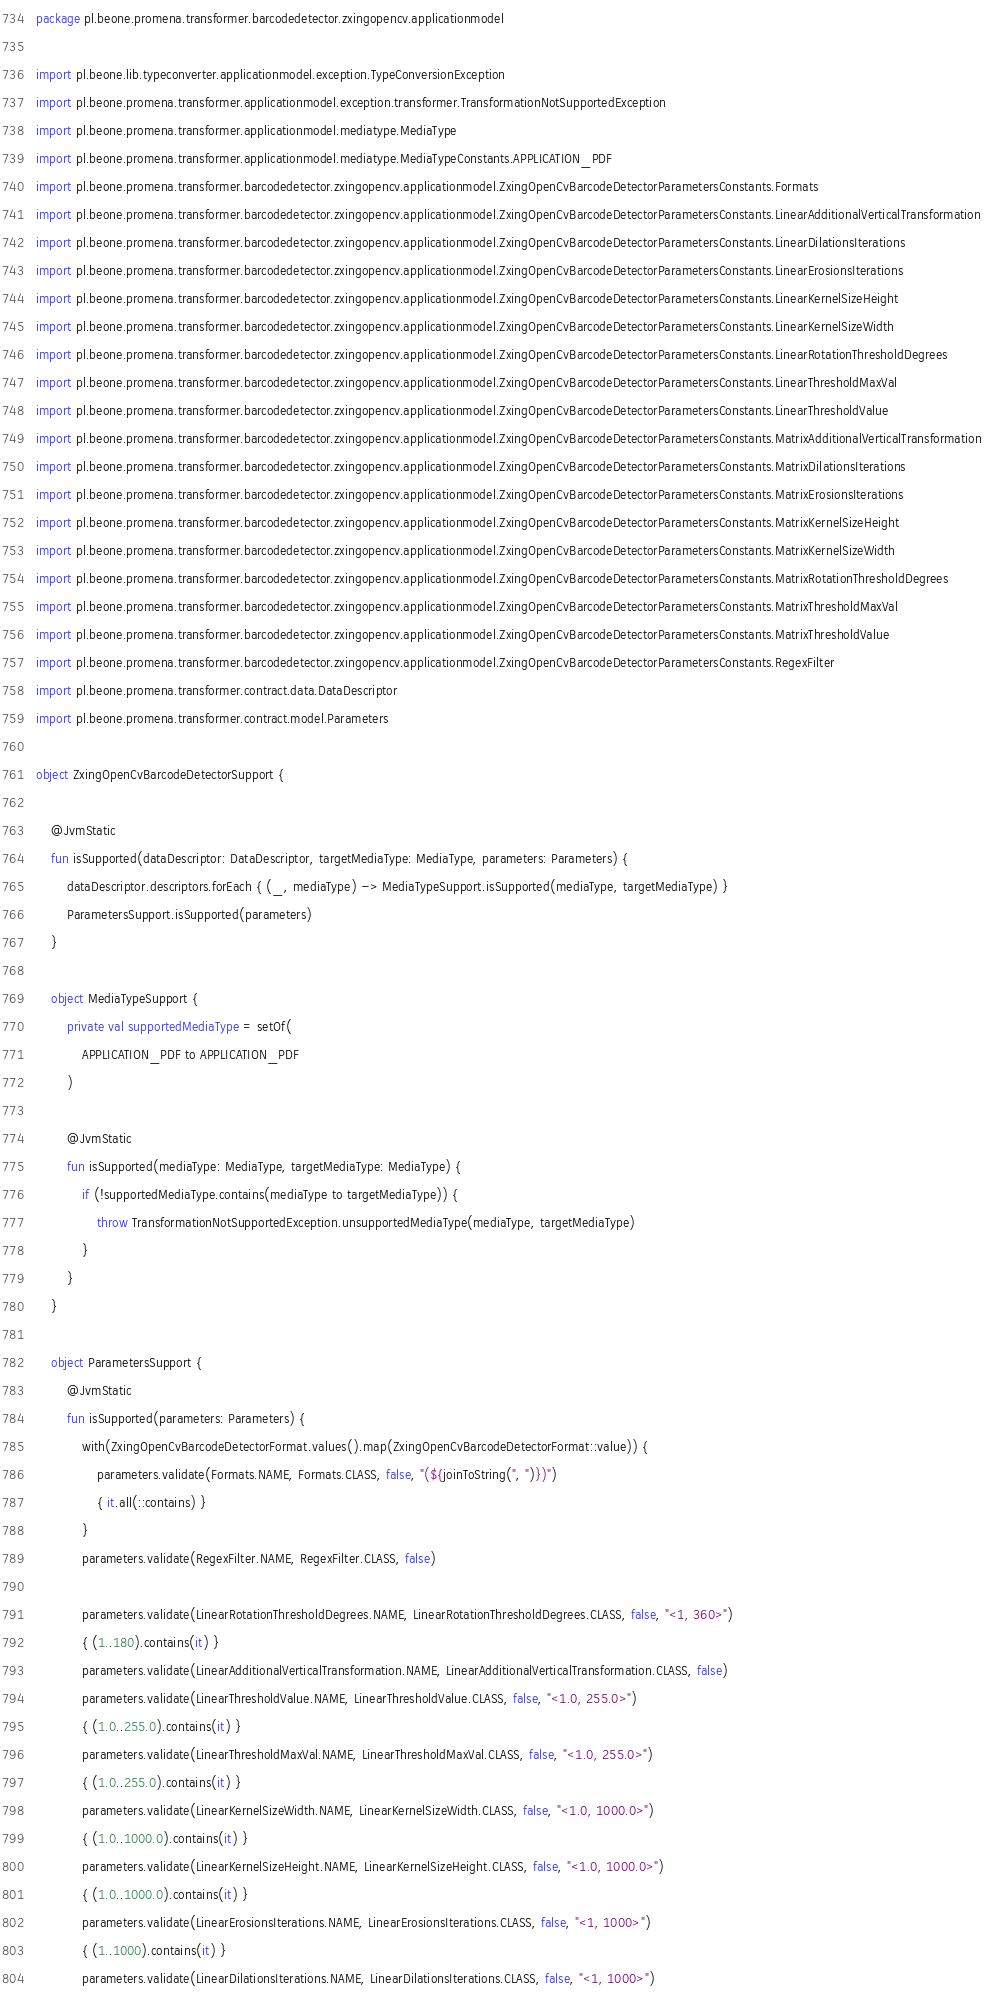<code> <loc_0><loc_0><loc_500><loc_500><_Kotlin_>package pl.beone.promena.transformer.barcodedetector.zxingopencv.applicationmodel

import pl.beone.lib.typeconverter.applicationmodel.exception.TypeConversionException
import pl.beone.promena.transformer.applicationmodel.exception.transformer.TransformationNotSupportedException
import pl.beone.promena.transformer.applicationmodel.mediatype.MediaType
import pl.beone.promena.transformer.applicationmodel.mediatype.MediaTypeConstants.APPLICATION_PDF
import pl.beone.promena.transformer.barcodedetector.zxingopencv.applicationmodel.ZxingOpenCvBarcodeDetectorParametersConstants.Formats
import pl.beone.promena.transformer.barcodedetector.zxingopencv.applicationmodel.ZxingOpenCvBarcodeDetectorParametersConstants.LinearAdditionalVerticalTransformation
import pl.beone.promena.transformer.barcodedetector.zxingopencv.applicationmodel.ZxingOpenCvBarcodeDetectorParametersConstants.LinearDilationsIterations
import pl.beone.promena.transformer.barcodedetector.zxingopencv.applicationmodel.ZxingOpenCvBarcodeDetectorParametersConstants.LinearErosionsIterations
import pl.beone.promena.transformer.barcodedetector.zxingopencv.applicationmodel.ZxingOpenCvBarcodeDetectorParametersConstants.LinearKernelSizeHeight
import pl.beone.promena.transformer.barcodedetector.zxingopencv.applicationmodel.ZxingOpenCvBarcodeDetectorParametersConstants.LinearKernelSizeWidth
import pl.beone.promena.transformer.barcodedetector.zxingopencv.applicationmodel.ZxingOpenCvBarcodeDetectorParametersConstants.LinearRotationThresholdDegrees
import pl.beone.promena.transformer.barcodedetector.zxingopencv.applicationmodel.ZxingOpenCvBarcodeDetectorParametersConstants.LinearThresholdMaxVal
import pl.beone.promena.transformer.barcodedetector.zxingopencv.applicationmodel.ZxingOpenCvBarcodeDetectorParametersConstants.LinearThresholdValue
import pl.beone.promena.transformer.barcodedetector.zxingopencv.applicationmodel.ZxingOpenCvBarcodeDetectorParametersConstants.MatrixAdditionalVerticalTransformation
import pl.beone.promena.transformer.barcodedetector.zxingopencv.applicationmodel.ZxingOpenCvBarcodeDetectorParametersConstants.MatrixDilationsIterations
import pl.beone.promena.transformer.barcodedetector.zxingopencv.applicationmodel.ZxingOpenCvBarcodeDetectorParametersConstants.MatrixErosionsIterations
import pl.beone.promena.transformer.barcodedetector.zxingopencv.applicationmodel.ZxingOpenCvBarcodeDetectorParametersConstants.MatrixKernelSizeHeight
import pl.beone.promena.transformer.barcodedetector.zxingopencv.applicationmodel.ZxingOpenCvBarcodeDetectorParametersConstants.MatrixKernelSizeWidth
import pl.beone.promena.transformer.barcodedetector.zxingopencv.applicationmodel.ZxingOpenCvBarcodeDetectorParametersConstants.MatrixRotationThresholdDegrees
import pl.beone.promena.transformer.barcodedetector.zxingopencv.applicationmodel.ZxingOpenCvBarcodeDetectorParametersConstants.MatrixThresholdMaxVal
import pl.beone.promena.transformer.barcodedetector.zxingopencv.applicationmodel.ZxingOpenCvBarcodeDetectorParametersConstants.MatrixThresholdValue
import pl.beone.promena.transformer.barcodedetector.zxingopencv.applicationmodel.ZxingOpenCvBarcodeDetectorParametersConstants.RegexFilter
import pl.beone.promena.transformer.contract.data.DataDescriptor
import pl.beone.promena.transformer.contract.model.Parameters

object ZxingOpenCvBarcodeDetectorSupport {

    @JvmStatic
    fun isSupported(dataDescriptor: DataDescriptor, targetMediaType: MediaType, parameters: Parameters) {
        dataDescriptor.descriptors.forEach { (_, mediaType) -> MediaTypeSupport.isSupported(mediaType, targetMediaType) }
        ParametersSupport.isSupported(parameters)
    }

    object MediaTypeSupport {
        private val supportedMediaType = setOf(
            APPLICATION_PDF to APPLICATION_PDF
        )

        @JvmStatic
        fun isSupported(mediaType: MediaType, targetMediaType: MediaType) {
            if (!supportedMediaType.contains(mediaType to targetMediaType)) {
                throw TransformationNotSupportedException.unsupportedMediaType(mediaType, targetMediaType)
            }
        }
    }

    object ParametersSupport {
        @JvmStatic
        fun isSupported(parameters: Parameters) {
            with(ZxingOpenCvBarcodeDetectorFormat.values().map(ZxingOpenCvBarcodeDetectorFormat::value)) {
                parameters.validate(Formats.NAME, Formats.CLASS, false, "(${joinToString(", ")})")
                { it.all(::contains) }
            }
            parameters.validate(RegexFilter.NAME, RegexFilter.CLASS, false)

            parameters.validate(LinearRotationThresholdDegrees.NAME, LinearRotationThresholdDegrees.CLASS, false, "<1, 360>")
            { (1..180).contains(it) }
            parameters.validate(LinearAdditionalVerticalTransformation.NAME, LinearAdditionalVerticalTransformation.CLASS, false)
            parameters.validate(LinearThresholdValue.NAME, LinearThresholdValue.CLASS, false, "<1.0, 255.0>")
            { (1.0..255.0).contains(it) }
            parameters.validate(LinearThresholdMaxVal.NAME, LinearThresholdMaxVal.CLASS, false, "<1.0, 255.0>")
            { (1.0..255.0).contains(it) }
            parameters.validate(LinearKernelSizeWidth.NAME, LinearKernelSizeWidth.CLASS, false, "<1.0, 1000.0>")
            { (1.0..1000.0).contains(it) }
            parameters.validate(LinearKernelSizeHeight.NAME, LinearKernelSizeHeight.CLASS, false, "<1.0, 1000.0>")
            { (1.0..1000.0).contains(it) }
            parameters.validate(LinearErosionsIterations.NAME, LinearErosionsIterations.CLASS, false, "<1, 1000>")
            { (1..1000).contains(it) }
            parameters.validate(LinearDilationsIterations.NAME, LinearDilationsIterations.CLASS, false, "<1, 1000>")</code> 